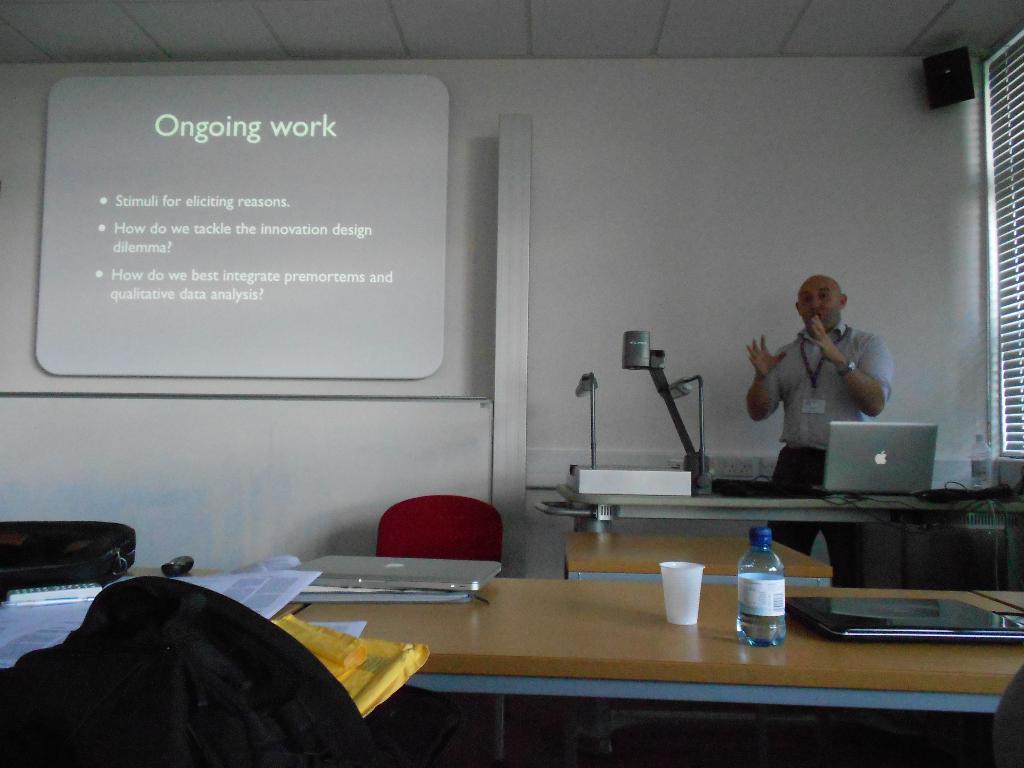In one or two sentences, can you explain what this image depicts? In the image there is a bald headed standing on the left side in front of table with laptop and an equipment on it, on the left side there is a screen on the wall, in the front there is table with water bottle,laptop,cups and books on it, this is clicked in the classroom. 